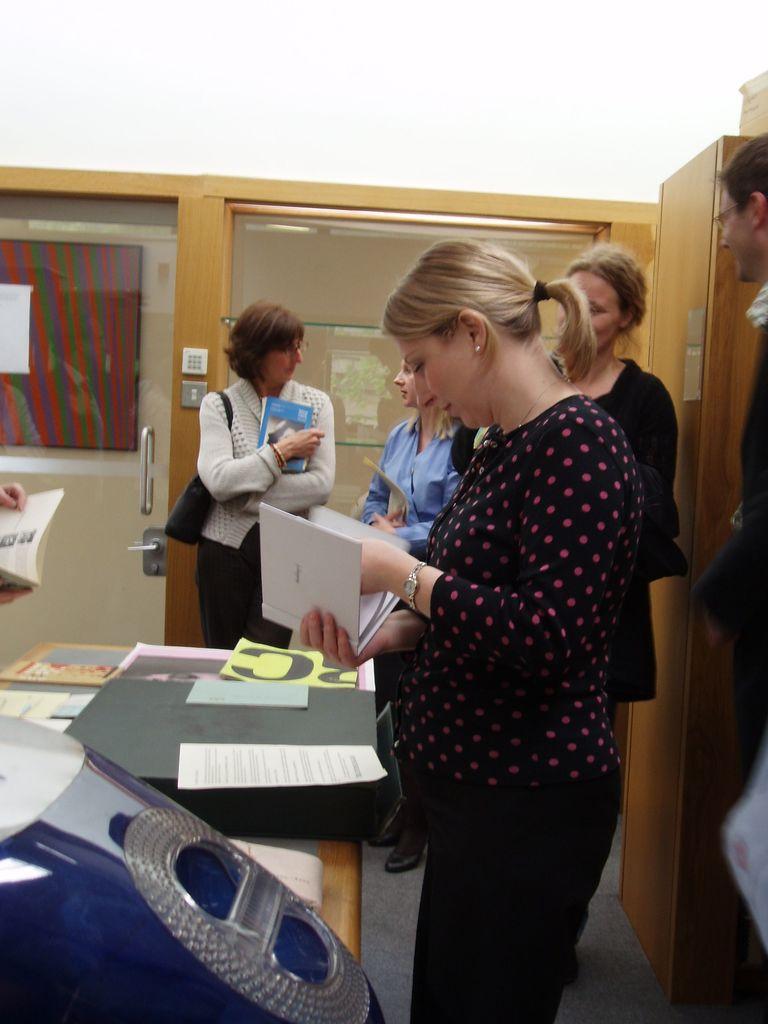In one or two sentences, can you explain what this image depicts? In this image I can see a woman wearing black and pink colored dress is standing and holding a book in her hand. I can see a table in front of her on which I can see few papers, a black colored object, a blue colored object and few other things. In the background I can see few persons standing, some wooden furniture, the white colored wall and the glass door. 